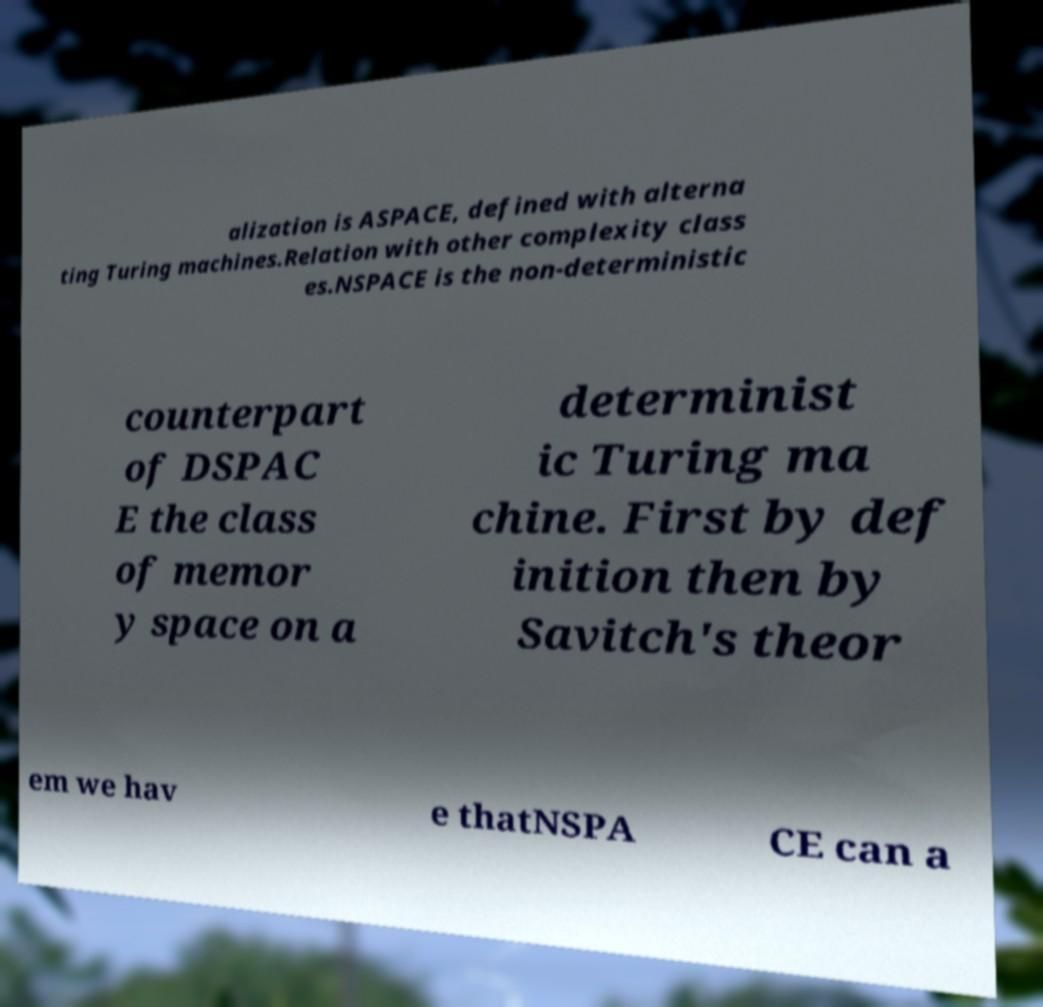Please read and relay the text visible in this image. What does it say? alization is ASPACE, defined with alterna ting Turing machines.Relation with other complexity class es.NSPACE is the non-deterministic counterpart of DSPAC E the class of memor y space on a determinist ic Turing ma chine. First by def inition then by Savitch's theor em we hav e thatNSPA CE can a 